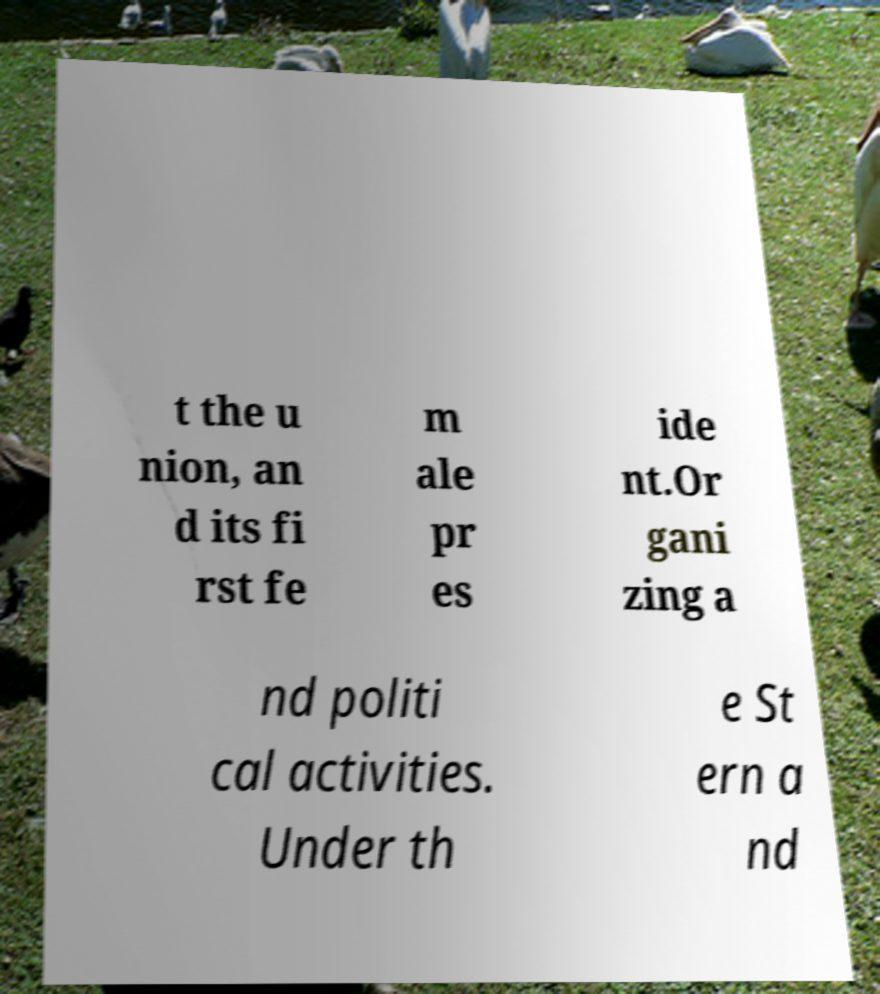Can you read and provide the text displayed in the image?This photo seems to have some interesting text. Can you extract and type it out for me? t the u nion, an d its fi rst fe m ale pr es ide nt.Or gani zing a nd politi cal activities. Under th e St ern a nd 